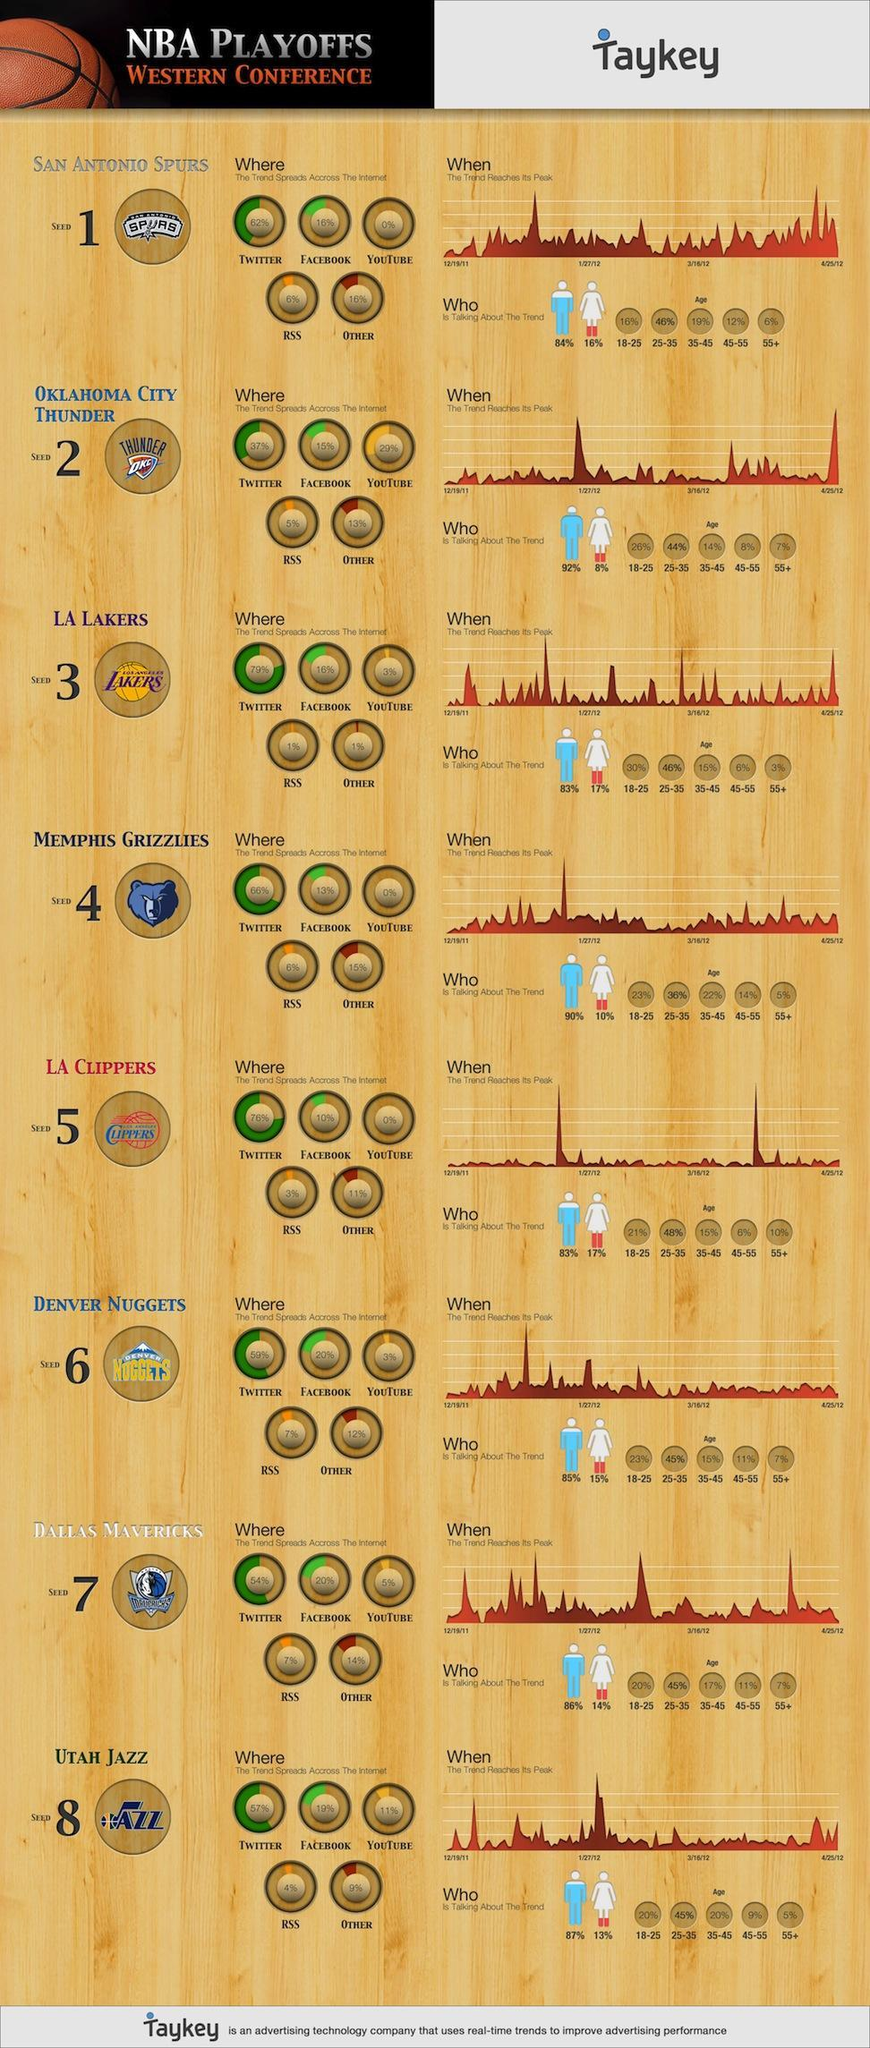In which social platform were "all"  the basketball teams most trending?
Answer the question with a short phrase. Twitter In which of these months, did Oklahoma City Thunder reach the trend peak - December, January or February? January How many platforms are used for social seeding? 5 Which 2 basketball teams are most trending among women? LA Lakers, LA Clippers Which age group is mostly talking about San Antonio Spurs? 25-35 What is the trend % of LA Clippers on Twitter? 76% Which basketball team is the most trending among men? Oklahoma City Thunder What percent of people in the age group 18-25 talk about Dallas Mavericks? 20% What percentage of women are talking about Oklahoma City Thunder? 8% What percentage of men are talking about San Antonio Spurs? 84% Which team is a most trending on YouTube? Oklahoma city thunder What percentage of people in the age group 35-45 are talking about Oklahoma City Thunder? 14% What is the trend percent of Utah Jazz on Facebook? 19% What percentage of women are talking about San Antonio Spurs? 16% What is the trend % of Memphis Grizzlies on Twitter? 66% Which team is represented by the picture of a bear? Memphis Grizzlies What percentage of men are talking about Oklahoma City Thunder? 92% Which of the basketball teams, is the most trending on twitter? LA Lakers What percentage of senior citizens are talking about San Antonio Spurs? 6% 